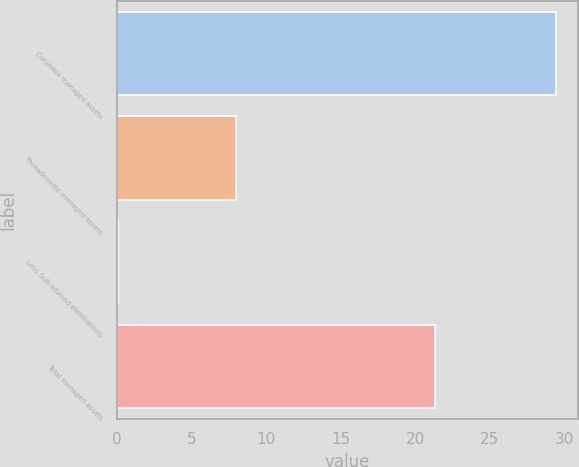<chart> <loc_0><loc_0><loc_500><loc_500><bar_chart><fcel>Columbia managed assets<fcel>Threadneedle managed assets<fcel>Less Sub-advised eliminations<fcel>Total managed assets<nl><fcel>29.4<fcel>8<fcel>0.1<fcel>21.3<nl></chart> 